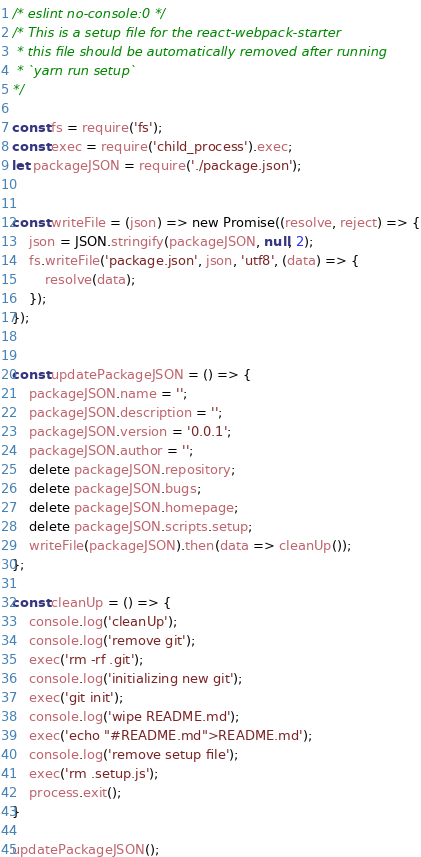Convert code to text. <code><loc_0><loc_0><loc_500><loc_500><_JavaScript_>/* eslint no-console:0 */
/* This is a setup file for the react-webpack-starter
 * this file should be automatically removed after running
 * `yarn run setup`
*/

const fs = require('fs');
const exec = require('child_process').exec;
let packageJSON = require('./package.json');


const writeFile = (json) => new Promise((resolve, reject) => {
    json = JSON.stringify(packageJSON, null, 2);
    fs.writeFile('package.json', json, 'utf8', (data) => {
        resolve(data);
    });
});


const updatePackageJSON = () => {
    packageJSON.name = '';
    packageJSON.description = '';
    packageJSON.version = '0.0.1';
    packageJSON.author = '';
    delete packageJSON.repository;
    delete packageJSON.bugs;
    delete packageJSON.homepage;
    delete packageJSON.scripts.setup;
    writeFile(packageJSON).then(data => cleanUp());
};

const cleanUp = () => {
    console.log('cleanUp');
    console.log('remove git');
    exec('rm -rf .git');
    console.log('initializing new git');
    exec('git init');
    console.log('wipe README.md');
    exec('echo "#README.md">README.md');
    console.log('remove setup file');
    exec('rm .setup.js');
    process.exit();
}

updatePackageJSON();
</code> 